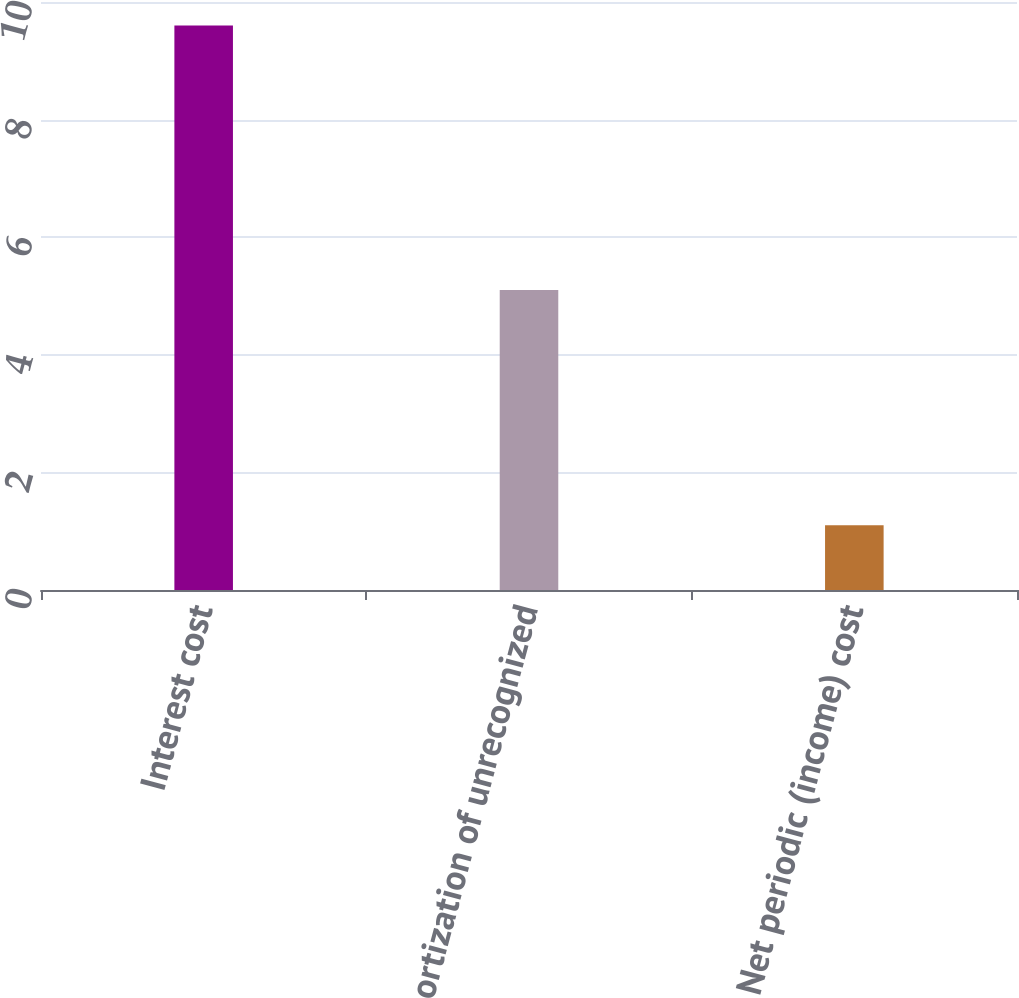Convert chart. <chart><loc_0><loc_0><loc_500><loc_500><bar_chart><fcel>Interest cost<fcel>Amortization of unrecognized<fcel>Net periodic (income) cost<nl><fcel>9.6<fcel>5.1<fcel>1.1<nl></chart> 